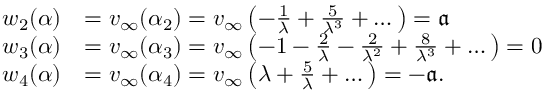<formula> <loc_0><loc_0><loc_500><loc_500>\begin{array} { r l } { w _ { 2 } ( \alpha ) } & { = v _ { \infty } ( \alpha _ { 2 } ) = v _ { \infty } \left ( - \frac { 1 } { \lambda } + \frac { 5 } { \lambda ^ { 3 } } + \dots \right ) = { \mathfrak a } } \\ { w _ { 3 } ( \alpha ) } & { = v _ { \infty } ( \alpha _ { 3 } ) = v _ { \infty } \left ( - 1 - \frac { 2 } { \lambda } - \frac { 2 } { \lambda ^ { 2 } } + \frac { 8 } { \lambda ^ { 3 } } + \dots \right ) = 0 } \\ { w _ { 4 } ( \alpha ) } & { = v _ { \infty } ( \alpha _ { 4 } ) = v _ { \infty } \left ( \lambda + \frac { 5 } { \lambda } + \dots \right ) = - { \mathfrak a } . } \end{array}</formula> 